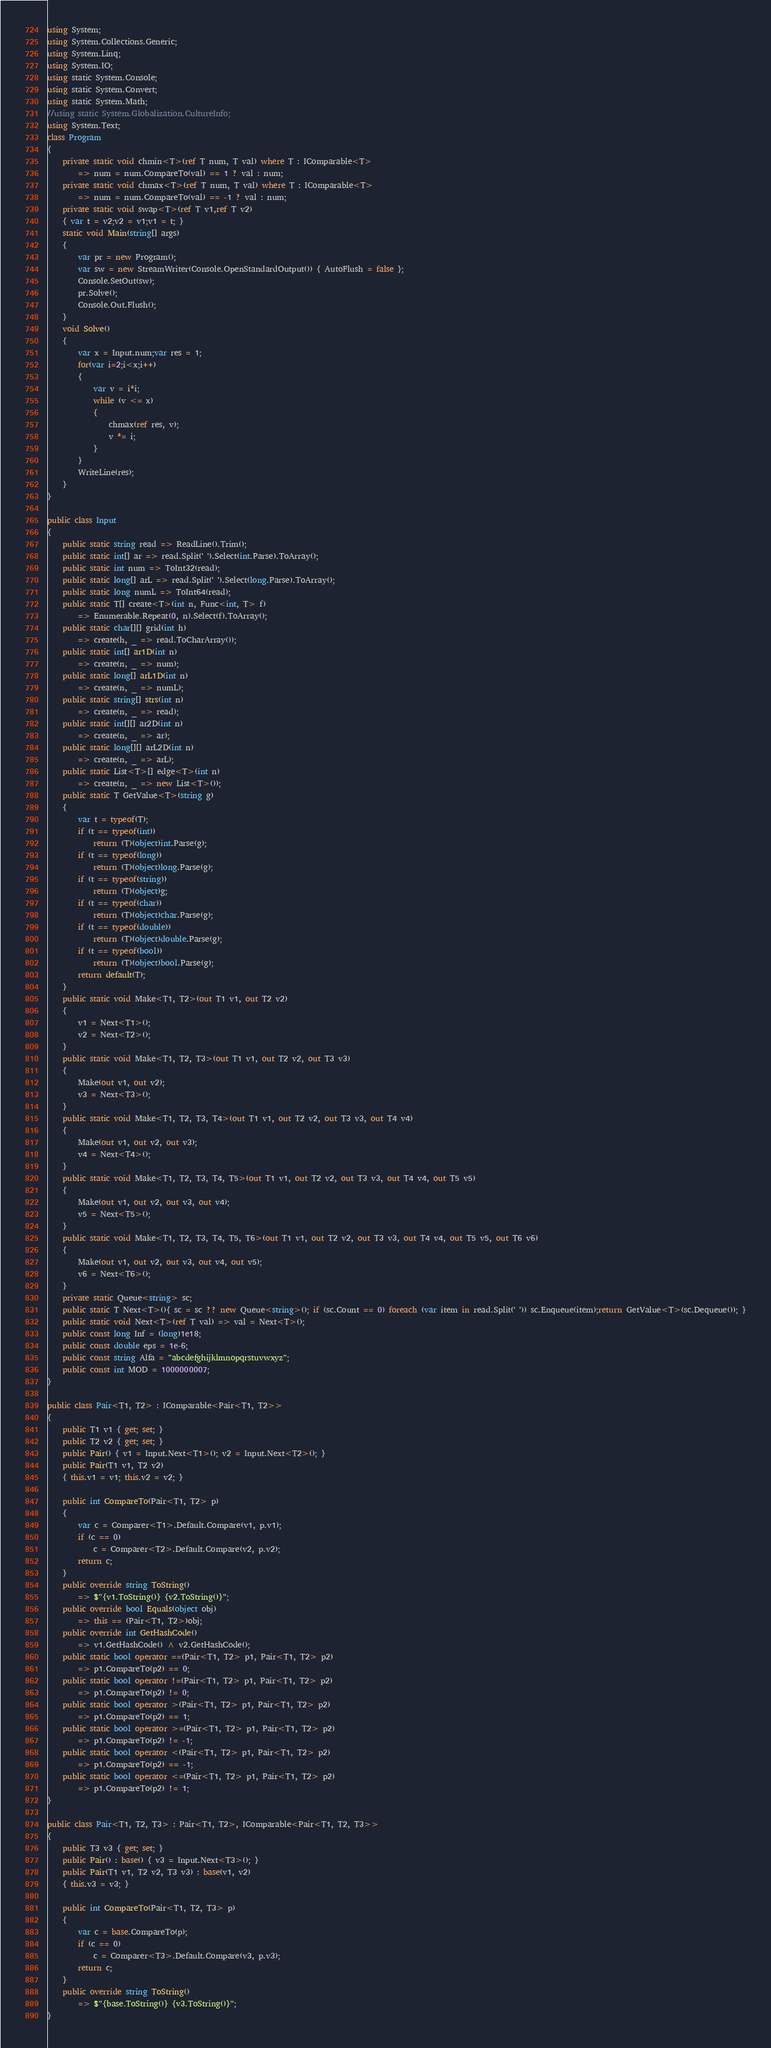<code> <loc_0><loc_0><loc_500><loc_500><_C#_>using System;
using System.Collections.Generic;
using System.Linq;
using System.IO;
using static System.Console;
using static System.Convert;
using static System.Math;
//using static System.Globalization.CultureInfo;
using System.Text;
class Program
{
    private static void chmin<T>(ref T num, T val) where T : IComparable<T>
        => num = num.CompareTo(val) == 1 ? val : num;
    private static void chmax<T>(ref T num, T val) where T : IComparable<T>
        => num = num.CompareTo(val) == -1 ? val : num;
    private static void swap<T>(ref T v1,ref T v2)
    { var t = v2;v2 = v1;v1 = t; }
    static void Main(string[] args)
    {
        var pr = new Program();
        var sw = new StreamWriter(Console.OpenStandardOutput()) { AutoFlush = false };
        Console.SetOut(sw);
        pr.Solve();
        Console.Out.Flush();
    }
    void Solve()
    {
        var x = Input.num;var res = 1;
        for(var i=2;i<x;i++)
        {
            var v = i*i;
            while (v <= x)
            {
                chmax(ref res, v);
                v *= i;
            }
        }
        WriteLine(res);
    }
}

public class Input
{
    public static string read => ReadLine().Trim();
    public static int[] ar => read.Split(' ').Select(int.Parse).ToArray();
    public static int num => ToInt32(read);
    public static long[] arL => read.Split(' ').Select(long.Parse).ToArray();
    public static long numL => ToInt64(read);
    public static T[] create<T>(int n, Func<int, T> f)
        => Enumerable.Repeat(0, n).Select(f).ToArray();
    public static char[][] grid(int h)
        => create(h, _ => read.ToCharArray());
    public static int[] ar1D(int n)
        => create(n, _ => num);
    public static long[] arL1D(int n)
        => create(n, _ => numL);
    public static string[] strs(int n)
        => create(n, _ => read);
    public static int[][] ar2D(int n)
        => create(n, _ => ar);
    public static long[][] arL2D(int n)
        => create(n, _ => arL);
    public static List<T>[] edge<T>(int n)
        => create(n, _ => new List<T>());
    public static T GetValue<T>(string g)
    {
        var t = typeof(T);
        if (t == typeof(int))
            return (T)(object)int.Parse(g);
        if (t == typeof(long))
            return (T)(object)long.Parse(g);
        if (t == typeof(string))
            return (T)(object)g;
        if (t == typeof(char))
            return (T)(object)char.Parse(g);
        if (t == typeof(double))
            return (T)(object)double.Parse(g);
        if (t == typeof(bool))
            return (T)(object)bool.Parse(g);
        return default(T);
    }
    public static void Make<T1, T2>(out T1 v1, out T2 v2)
    {
        v1 = Next<T1>();
        v2 = Next<T2>();
    }
    public static void Make<T1, T2, T3>(out T1 v1, out T2 v2, out T3 v3)
    {
        Make(out v1, out v2);
        v3 = Next<T3>();
    }
    public static void Make<T1, T2, T3, T4>(out T1 v1, out T2 v2, out T3 v3, out T4 v4)
    {
        Make(out v1, out v2, out v3);
        v4 = Next<T4>();
    }
    public static void Make<T1, T2, T3, T4, T5>(out T1 v1, out T2 v2, out T3 v3, out T4 v4, out T5 v5)
    {
        Make(out v1, out v2, out v3, out v4);
        v5 = Next<T5>();
    }
    public static void Make<T1, T2, T3, T4, T5, T6>(out T1 v1, out T2 v2, out T3 v3, out T4 v4, out T5 v5, out T6 v6)
    {
        Make(out v1, out v2, out v3, out v4, out v5);
        v6 = Next<T6>();
    }
    private static Queue<string> sc;
    public static T Next<T>(){ sc = sc ?? new Queue<string>(); if (sc.Count == 0) foreach (var item in read.Split(' ')) sc.Enqueue(item);return GetValue<T>(sc.Dequeue()); }
    public static void Next<T>(ref T val) => val = Next<T>(); 
    public const long Inf = (long)1e18;
    public const double eps = 1e-6;
    public const string Alfa = "abcdefghijklmnopqrstuvwxyz";
    public const int MOD = 1000000007;
}

public class Pair<T1, T2> : IComparable<Pair<T1, T2>>
{
    public T1 v1 { get; set; }
    public T2 v2 { get; set; }
    public Pair() { v1 = Input.Next<T1>(); v2 = Input.Next<T2>(); }
    public Pair(T1 v1, T2 v2)
    { this.v1 = v1; this.v2 = v2; }

    public int CompareTo(Pair<T1, T2> p)
    {
        var c = Comparer<T1>.Default.Compare(v1, p.v1);
        if (c == 0)
            c = Comparer<T2>.Default.Compare(v2, p.v2);
        return c;
    }
    public override string ToString()
        => $"{v1.ToString()} {v2.ToString()}";
    public override bool Equals(object obj)
        => this == (Pair<T1, T2>)obj;
    public override int GetHashCode()
        => v1.GetHashCode() ^ v2.GetHashCode();
    public static bool operator ==(Pair<T1, T2> p1, Pair<T1, T2> p2)
        => p1.CompareTo(p2) == 0;
    public static bool operator !=(Pair<T1, T2> p1, Pair<T1, T2> p2)
        => p1.CompareTo(p2) != 0;
    public static bool operator >(Pair<T1, T2> p1, Pair<T1, T2> p2)
        => p1.CompareTo(p2) == 1;
    public static bool operator >=(Pair<T1, T2> p1, Pair<T1, T2> p2)
        => p1.CompareTo(p2) != -1;
    public static bool operator <(Pair<T1, T2> p1, Pair<T1, T2> p2)
        => p1.CompareTo(p2) == -1;
    public static bool operator <=(Pair<T1, T2> p1, Pair<T1, T2> p2)
        => p1.CompareTo(p2) != 1;
}

public class Pair<T1, T2, T3> : Pair<T1, T2>, IComparable<Pair<T1, T2, T3>>
{
    public T3 v3 { get; set; }
    public Pair() : base() { v3 = Input.Next<T3>(); }
    public Pair(T1 v1, T2 v2, T3 v3) : base(v1, v2)
    { this.v3 = v3; }

    public int CompareTo(Pair<T1, T2, T3> p)
    {
        var c = base.CompareTo(p);
        if (c == 0)
            c = Comparer<T3>.Default.Compare(v3, p.v3);
        return c;
    }
    public override string ToString()
        => $"{base.ToString()} {v3.ToString()}";
}
</code> 